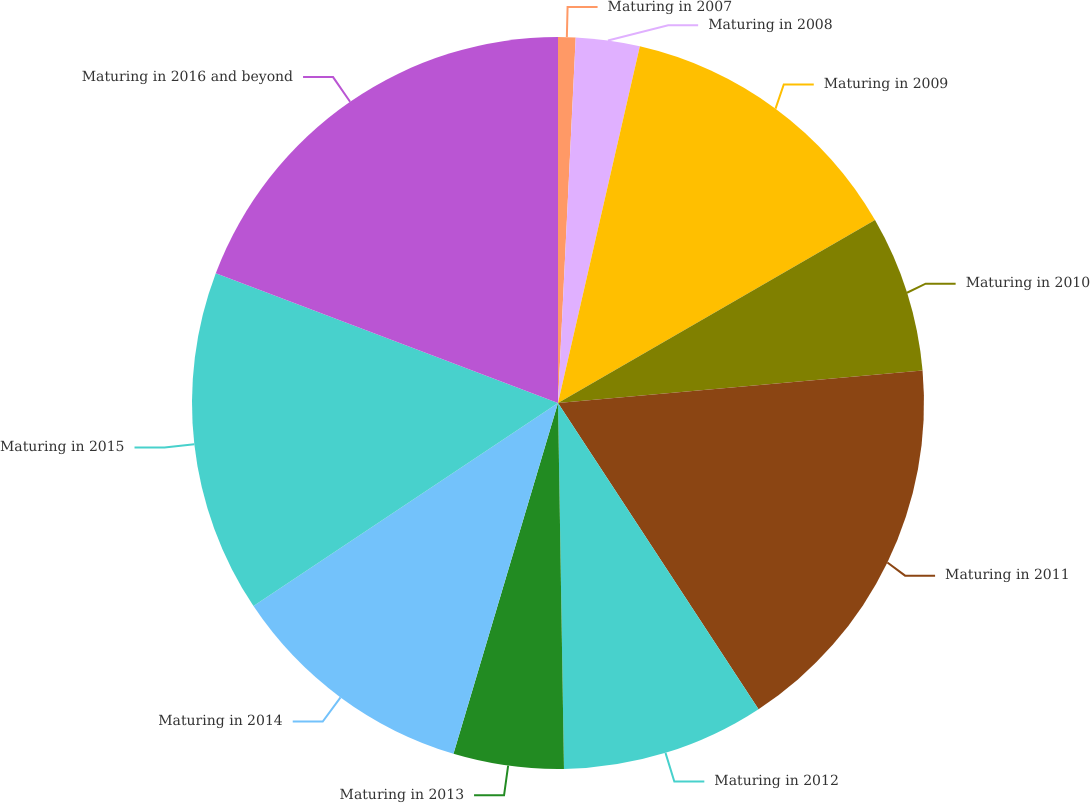<chart> <loc_0><loc_0><loc_500><loc_500><pie_chart><fcel>Maturing in 2007<fcel>Maturing in 2008<fcel>Maturing in 2009<fcel>Maturing in 2010<fcel>Maturing in 2011<fcel>Maturing in 2012<fcel>Maturing in 2013<fcel>Maturing in 2014<fcel>Maturing in 2015<fcel>Maturing in 2016 and beyond<nl><fcel>0.77%<fcel>2.82%<fcel>13.08%<fcel>6.92%<fcel>17.18%<fcel>8.97%<fcel>4.87%<fcel>11.03%<fcel>15.13%<fcel>19.23%<nl></chart> 